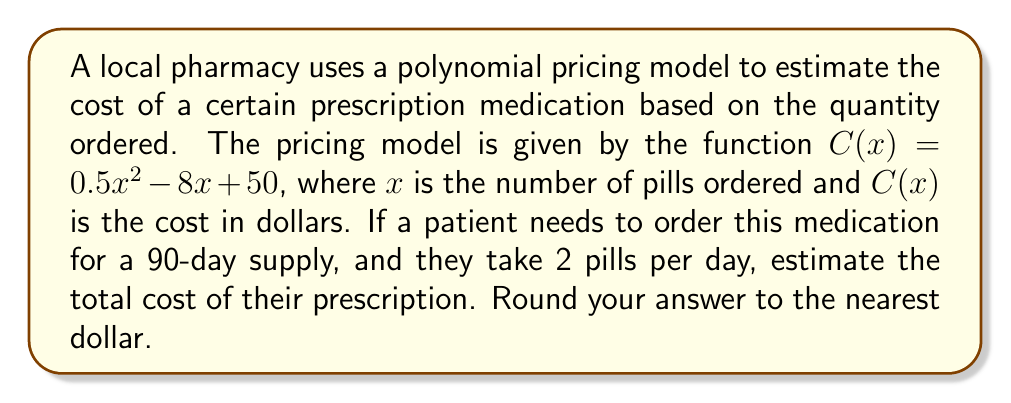Can you solve this math problem? Let's approach this problem step-by-step:

1) First, we need to determine the number of pills needed for a 90-day supply:
   $\text{Number of pills} = 90 \text{ days} \times 2 \text{ pills per day} = 180 \text{ pills}$

2) Now that we know the quantity, we can use the polynomial pricing model to calculate the cost:
   $C(x) = 0.5x^2 - 8x + 50$
   
   We need to evaluate $C(180)$:

3) $C(180) = 0.5(180)^2 - 8(180) + 50$

4) Let's calculate each term:
   $0.5(180)^2 = 0.5 \times 32400 = 16200$
   $-8(180) = -1440$
   $50$ remains as is

5) Now, let's sum these terms:
   $C(180) = 16200 - 1440 + 50 = 14810$

6) The question asks to round to the nearest dollar, so our final answer is $14,810$.
Answer: $14,810 